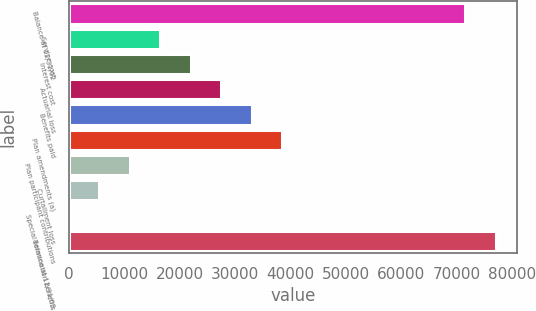Convert chart. <chart><loc_0><loc_0><loc_500><loc_500><bar_chart><fcel>Balance at 12/31/02<fcel>Service cost<fcel>Interest cost<fcel>Actuarial loss<fcel>Benefits paid<fcel>Plan amendments (a)<fcel>Plan participant contributions<fcel>Curtailment loss<fcel>Special termination benefits<fcel>Balance at 12/31/03<nl><fcel>71572.2<fcel>16538.2<fcel>22041.6<fcel>27545<fcel>33048.4<fcel>38551.8<fcel>11034.8<fcel>5531.4<fcel>28<fcel>77075.6<nl></chart> 